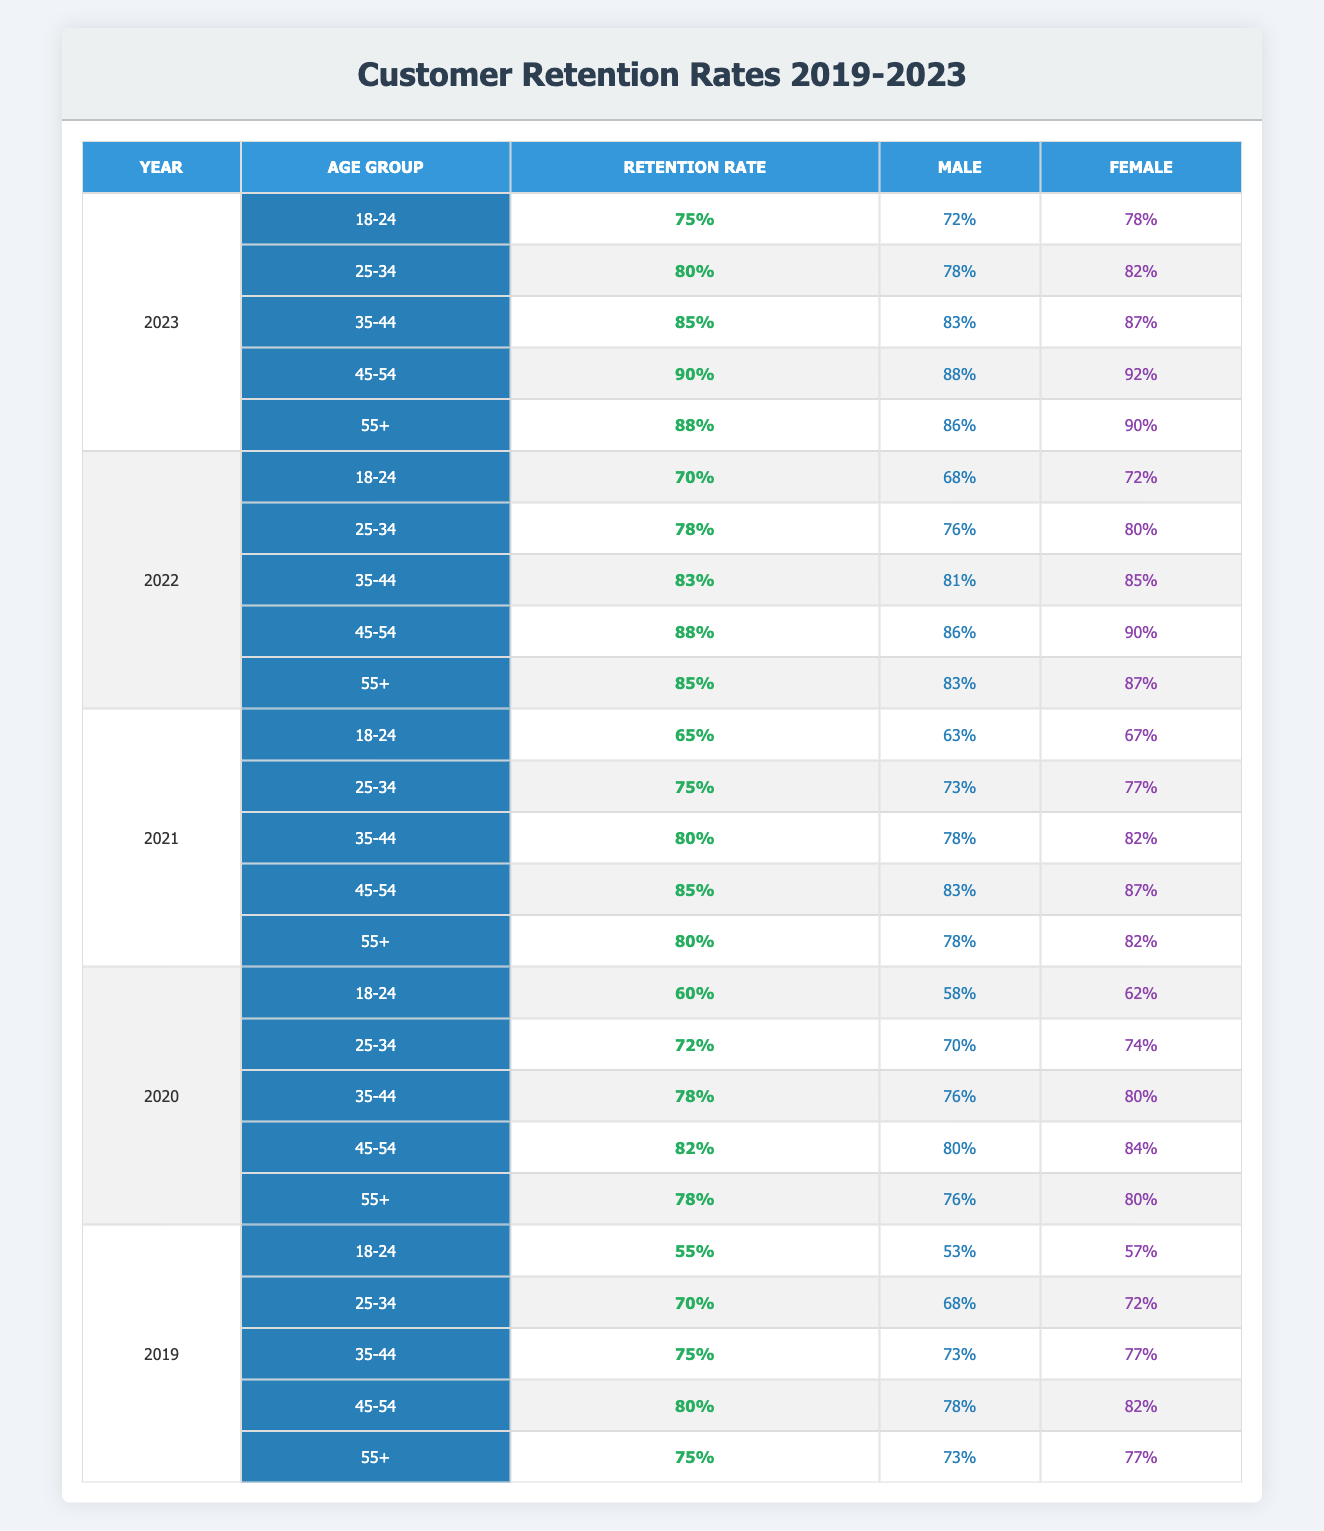What was the retention rate for the age group 25-34 in 2023? The table shows that in 2023, the retention rate for the age group 25-34 is 80%.
Answer: 80% Which age group had the highest retention rate in 2021? In 2021, the highest retention rate is 85%, which belongs to the age group 45-54.
Answer: 45-54 Was the retention rate for females higher than that for males in the age group 18-24 for 2022? In 2022, the retention rate for males is 68% and for females is 72%, which indicates that females had a higher retention rate than males.
Answer: Yes What is the average retention rate for the age group 55+ across the years 2019 to 2023? The retention rates for the age group 55+ are 75% (2019), 78% (2020), 80% (2021), 85% (2022), and 88% (2023). Adding these rates gives 406%, and dividing by 5 (the number of years) results in an average of 81.2%.
Answer: 81.2% Is it true that the retention rate for males in the age group 35-44 improved from 2020 to 2023? The retention rate for males in the age group 35-44 was 76% in 2020 and increased to 83% in 2023, confirming that it did improve.
Answer: Yes What was the difference in the retention rate for the age group 18-24 between 2019 and 2023? The retention rate for 2019 was 55%, while for 2023 it was 75%. The difference is 75% - 55% = 20%.
Answer: 20% Which age group had a higher retention rate in 2020: 45-54 or 55+? In 2020, the retention rate for 45-54 was 82% and for 55+ was 78%, meaning 45-54 had a higher rate.
Answer: 45-54 What percentage of males aged 25-34 retained their customers in 2022? According to the table, males aged 25-34 had a retention rate of 76% in 2022.
Answer: 76% How much did the retention rate decrease for the age group 18-24 from 2019 to 2021? The retention rate for the age group 18-24 was 55% in 2019 and dropped to 65% in 2021. The decrease is 65% - 55% = 10%.
Answer: 10% 